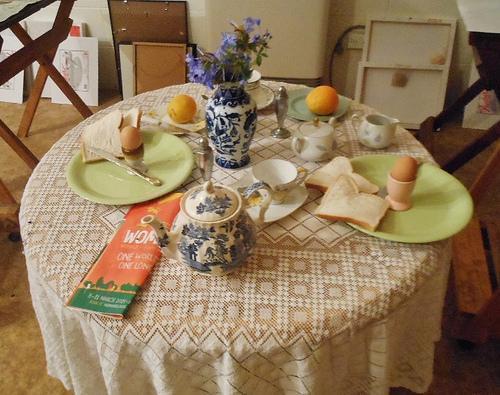How many pieces of bread are on the table?
Give a very brief answer. 4. 